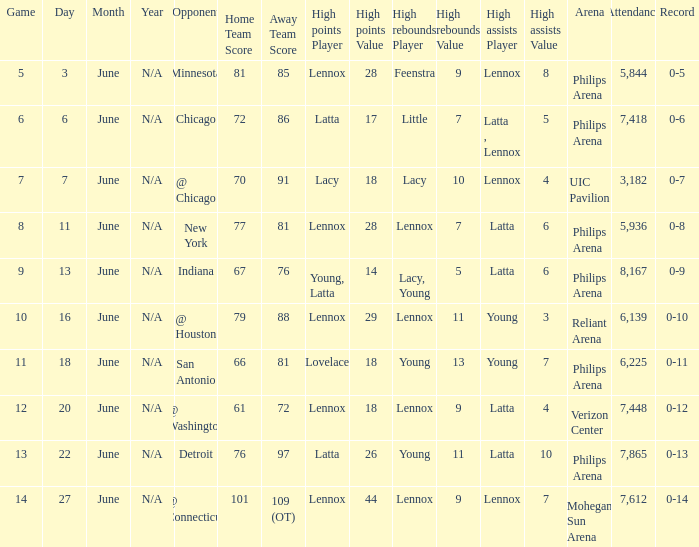Which venue held the game on june 7 and what was the attendance figure? UIC Pavilion 3,182. 